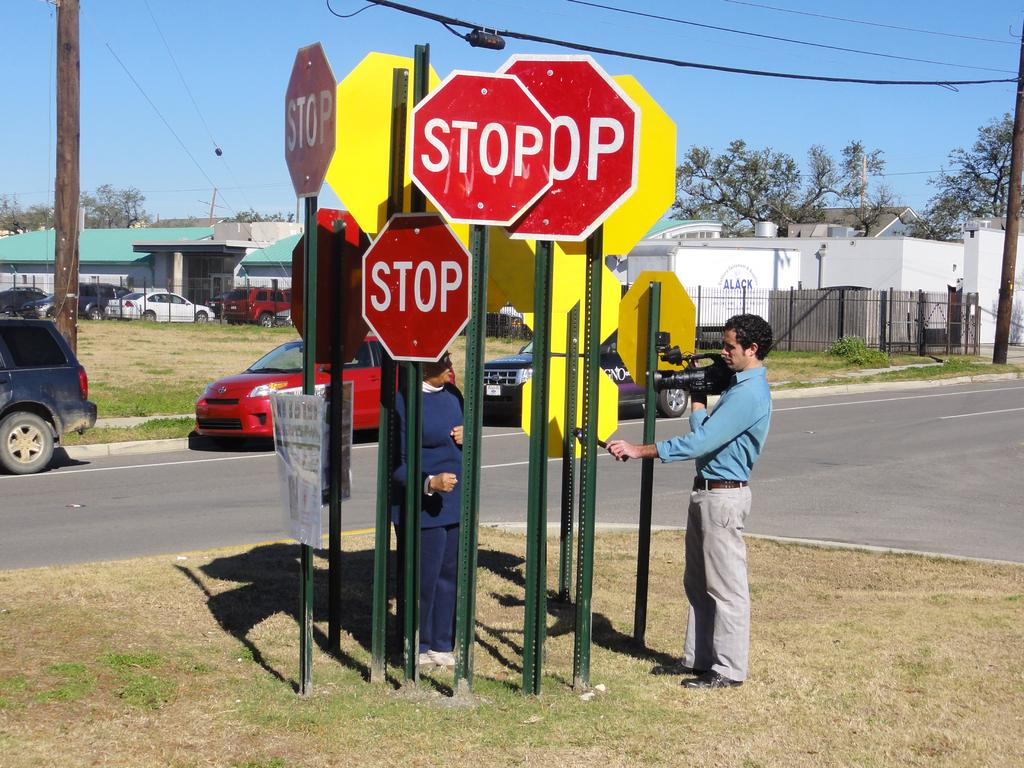<image>
Share a concise interpretation of the image provided. Two people adjust a group of Stop signs. 